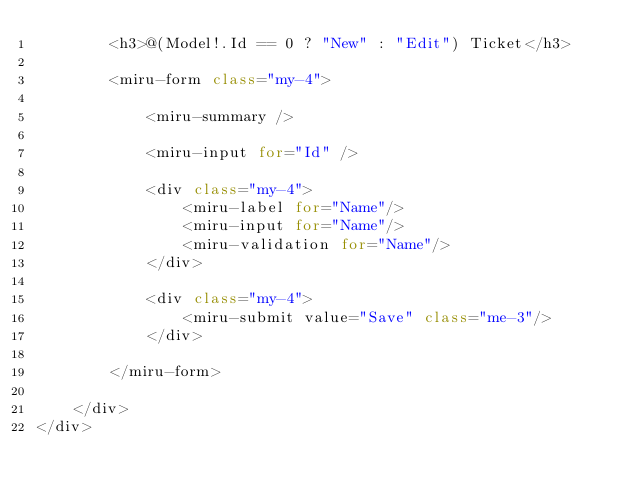Convert code to text. <code><loc_0><loc_0><loc_500><loc_500><_C#_>        <h3>@(Model!.Id == 0 ? "New" : "Edit") Ticket</h3>
        
        <miru-form class="my-4">

            <miru-summary />

            <miru-input for="Id" />

            <div class="my-4">
                <miru-label for="Name"/>
                <miru-input for="Name"/>
                <miru-validation for="Name"/>
            </div>

            <div class="my-4">
                <miru-submit value="Save" class="me-3"/>
            </div>
            
        </miru-form>
    
    </div>
</div></code> 